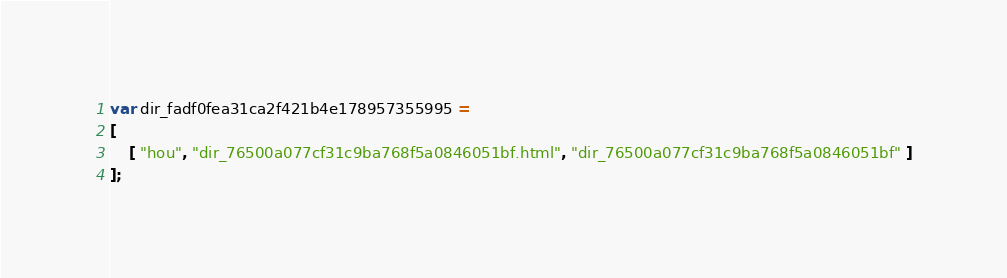<code> <loc_0><loc_0><loc_500><loc_500><_JavaScript_>var dir_fadf0fea31ca2f421b4e178957355995 =
[
    [ "hou", "dir_76500a077cf31c9ba768f5a0846051bf.html", "dir_76500a077cf31c9ba768f5a0846051bf" ]
];</code> 